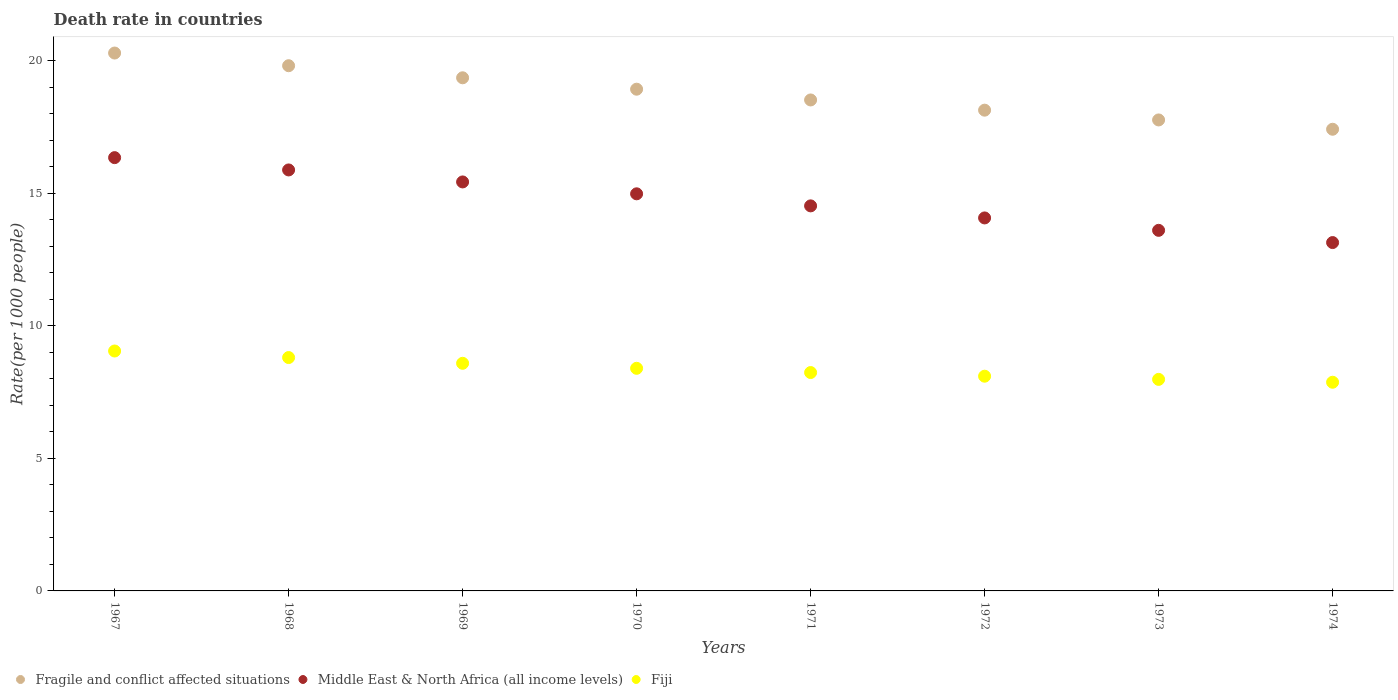How many different coloured dotlines are there?
Your answer should be very brief. 3. Is the number of dotlines equal to the number of legend labels?
Offer a very short reply. Yes. What is the death rate in Fragile and conflict affected situations in 1973?
Your answer should be compact. 17.77. Across all years, what is the maximum death rate in Fiji?
Give a very brief answer. 9.05. Across all years, what is the minimum death rate in Fiji?
Your answer should be very brief. 7.88. In which year was the death rate in Fragile and conflict affected situations maximum?
Keep it short and to the point. 1967. In which year was the death rate in Fragile and conflict affected situations minimum?
Provide a succinct answer. 1974. What is the total death rate in Fragile and conflict affected situations in the graph?
Your answer should be very brief. 150.28. What is the difference between the death rate in Middle East & North Africa (all income levels) in 1968 and that in 1973?
Your answer should be very brief. 2.28. What is the difference between the death rate in Middle East & North Africa (all income levels) in 1969 and the death rate in Fiji in 1973?
Ensure brevity in your answer.  7.45. What is the average death rate in Middle East & North Africa (all income levels) per year?
Provide a succinct answer. 14.75. In the year 1974, what is the difference between the death rate in Fiji and death rate in Fragile and conflict affected situations?
Your answer should be compact. -9.55. In how many years, is the death rate in Middle East & North Africa (all income levels) greater than 15?
Provide a succinct answer. 3. What is the ratio of the death rate in Fiji in 1969 to that in 1974?
Provide a succinct answer. 1.09. Is the death rate in Fiji in 1969 less than that in 1972?
Offer a terse response. No. What is the difference between the highest and the second highest death rate in Fragile and conflict affected situations?
Your response must be concise. 0.48. What is the difference between the highest and the lowest death rate in Fiji?
Ensure brevity in your answer.  1.18. In how many years, is the death rate in Fiji greater than the average death rate in Fiji taken over all years?
Give a very brief answer. 4. Is the sum of the death rate in Fragile and conflict affected situations in 1970 and 1972 greater than the maximum death rate in Fiji across all years?
Provide a short and direct response. Yes. Is it the case that in every year, the sum of the death rate in Fiji and death rate in Middle East & North Africa (all income levels)  is greater than the death rate in Fragile and conflict affected situations?
Provide a short and direct response. Yes. Is the death rate in Fragile and conflict affected situations strictly greater than the death rate in Fiji over the years?
Your answer should be very brief. Yes. Is the death rate in Fragile and conflict affected situations strictly less than the death rate in Middle East & North Africa (all income levels) over the years?
Provide a succinct answer. No. How many dotlines are there?
Ensure brevity in your answer.  3. What is the difference between two consecutive major ticks on the Y-axis?
Keep it short and to the point. 5. Are the values on the major ticks of Y-axis written in scientific E-notation?
Provide a short and direct response. No. Does the graph contain any zero values?
Offer a very short reply. No. Does the graph contain grids?
Give a very brief answer. No. Where does the legend appear in the graph?
Give a very brief answer. Bottom left. How are the legend labels stacked?
Offer a terse response. Horizontal. What is the title of the graph?
Make the answer very short. Death rate in countries. Does "Benin" appear as one of the legend labels in the graph?
Your answer should be compact. No. What is the label or title of the X-axis?
Make the answer very short. Years. What is the label or title of the Y-axis?
Your response must be concise. Rate(per 1000 people). What is the Rate(per 1000 people) of Fragile and conflict affected situations in 1967?
Offer a very short reply. 20.3. What is the Rate(per 1000 people) in Middle East & North Africa (all income levels) in 1967?
Provide a short and direct response. 16.35. What is the Rate(per 1000 people) of Fiji in 1967?
Provide a short and direct response. 9.05. What is the Rate(per 1000 people) in Fragile and conflict affected situations in 1968?
Ensure brevity in your answer.  19.82. What is the Rate(per 1000 people) in Middle East & North Africa (all income levels) in 1968?
Provide a short and direct response. 15.89. What is the Rate(per 1000 people) in Fiji in 1968?
Ensure brevity in your answer.  8.81. What is the Rate(per 1000 people) of Fragile and conflict affected situations in 1969?
Make the answer very short. 19.36. What is the Rate(per 1000 people) in Middle East & North Africa (all income levels) in 1969?
Provide a short and direct response. 15.43. What is the Rate(per 1000 people) in Fiji in 1969?
Make the answer very short. 8.59. What is the Rate(per 1000 people) in Fragile and conflict affected situations in 1970?
Your answer should be very brief. 18.93. What is the Rate(per 1000 people) in Middle East & North Africa (all income levels) in 1970?
Offer a terse response. 14.99. What is the Rate(per 1000 people) of Fiji in 1970?
Provide a succinct answer. 8.4. What is the Rate(per 1000 people) of Fragile and conflict affected situations in 1971?
Your answer should be compact. 18.53. What is the Rate(per 1000 people) in Middle East & North Africa (all income levels) in 1971?
Your answer should be very brief. 14.53. What is the Rate(per 1000 people) of Fiji in 1971?
Keep it short and to the point. 8.24. What is the Rate(per 1000 people) of Fragile and conflict affected situations in 1972?
Offer a very short reply. 18.14. What is the Rate(per 1000 people) of Middle East & North Africa (all income levels) in 1972?
Provide a succinct answer. 14.08. What is the Rate(per 1000 people) of Fiji in 1972?
Offer a terse response. 8.1. What is the Rate(per 1000 people) in Fragile and conflict affected situations in 1973?
Your response must be concise. 17.77. What is the Rate(per 1000 people) in Middle East & North Africa (all income levels) in 1973?
Provide a short and direct response. 13.61. What is the Rate(per 1000 people) of Fiji in 1973?
Your answer should be compact. 7.98. What is the Rate(per 1000 people) in Fragile and conflict affected situations in 1974?
Ensure brevity in your answer.  17.42. What is the Rate(per 1000 people) of Middle East & North Africa (all income levels) in 1974?
Offer a terse response. 13.15. What is the Rate(per 1000 people) in Fiji in 1974?
Offer a terse response. 7.88. Across all years, what is the maximum Rate(per 1000 people) of Fragile and conflict affected situations?
Provide a short and direct response. 20.3. Across all years, what is the maximum Rate(per 1000 people) in Middle East & North Africa (all income levels)?
Offer a terse response. 16.35. Across all years, what is the maximum Rate(per 1000 people) of Fiji?
Give a very brief answer. 9.05. Across all years, what is the minimum Rate(per 1000 people) of Fragile and conflict affected situations?
Your response must be concise. 17.42. Across all years, what is the minimum Rate(per 1000 people) of Middle East & North Africa (all income levels)?
Your answer should be very brief. 13.15. Across all years, what is the minimum Rate(per 1000 people) in Fiji?
Provide a succinct answer. 7.88. What is the total Rate(per 1000 people) of Fragile and conflict affected situations in the graph?
Your response must be concise. 150.28. What is the total Rate(per 1000 people) of Middle East & North Africa (all income levels) in the graph?
Ensure brevity in your answer.  118.02. What is the total Rate(per 1000 people) of Fiji in the graph?
Provide a short and direct response. 67.05. What is the difference between the Rate(per 1000 people) of Fragile and conflict affected situations in 1967 and that in 1968?
Give a very brief answer. 0.48. What is the difference between the Rate(per 1000 people) in Middle East & North Africa (all income levels) in 1967 and that in 1968?
Offer a very short reply. 0.46. What is the difference between the Rate(per 1000 people) in Fiji in 1967 and that in 1968?
Offer a very short reply. 0.25. What is the difference between the Rate(per 1000 people) of Fragile and conflict affected situations in 1967 and that in 1969?
Give a very brief answer. 0.93. What is the difference between the Rate(per 1000 people) of Middle East & North Africa (all income levels) in 1967 and that in 1969?
Your response must be concise. 0.92. What is the difference between the Rate(per 1000 people) in Fiji in 1967 and that in 1969?
Keep it short and to the point. 0.46. What is the difference between the Rate(per 1000 people) of Fragile and conflict affected situations in 1967 and that in 1970?
Your answer should be very brief. 1.36. What is the difference between the Rate(per 1000 people) of Middle East & North Africa (all income levels) in 1967 and that in 1970?
Ensure brevity in your answer.  1.37. What is the difference between the Rate(per 1000 people) of Fiji in 1967 and that in 1970?
Your answer should be compact. 0.65. What is the difference between the Rate(per 1000 people) in Fragile and conflict affected situations in 1967 and that in 1971?
Keep it short and to the point. 1.77. What is the difference between the Rate(per 1000 people) in Middle East & North Africa (all income levels) in 1967 and that in 1971?
Keep it short and to the point. 1.82. What is the difference between the Rate(per 1000 people) of Fiji in 1967 and that in 1971?
Offer a terse response. 0.81. What is the difference between the Rate(per 1000 people) of Fragile and conflict affected situations in 1967 and that in 1972?
Offer a very short reply. 2.16. What is the difference between the Rate(per 1000 people) of Middle East & North Africa (all income levels) in 1967 and that in 1972?
Make the answer very short. 2.28. What is the difference between the Rate(per 1000 people) in Fiji in 1967 and that in 1972?
Give a very brief answer. 0.95. What is the difference between the Rate(per 1000 people) in Fragile and conflict affected situations in 1967 and that in 1973?
Offer a very short reply. 2.52. What is the difference between the Rate(per 1000 people) of Middle East & North Africa (all income levels) in 1967 and that in 1973?
Offer a very short reply. 2.74. What is the difference between the Rate(per 1000 people) of Fiji in 1967 and that in 1973?
Give a very brief answer. 1.07. What is the difference between the Rate(per 1000 people) in Fragile and conflict affected situations in 1967 and that in 1974?
Keep it short and to the point. 2.88. What is the difference between the Rate(per 1000 people) of Middle East & North Africa (all income levels) in 1967 and that in 1974?
Give a very brief answer. 3.21. What is the difference between the Rate(per 1000 people) of Fiji in 1967 and that in 1974?
Your answer should be compact. 1.18. What is the difference between the Rate(per 1000 people) in Fragile and conflict affected situations in 1968 and that in 1969?
Ensure brevity in your answer.  0.46. What is the difference between the Rate(per 1000 people) in Middle East & North Africa (all income levels) in 1968 and that in 1969?
Your answer should be very brief. 0.45. What is the difference between the Rate(per 1000 people) in Fiji in 1968 and that in 1969?
Keep it short and to the point. 0.22. What is the difference between the Rate(per 1000 people) of Fragile and conflict affected situations in 1968 and that in 1970?
Your answer should be very brief. 0.89. What is the difference between the Rate(per 1000 people) in Middle East & North Africa (all income levels) in 1968 and that in 1970?
Your response must be concise. 0.9. What is the difference between the Rate(per 1000 people) in Fiji in 1968 and that in 1970?
Provide a succinct answer. 0.41. What is the difference between the Rate(per 1000 people) in Fragile and conflict affected situations in 1968 and that in 1971?
Make the answer very short. 1.29. What is the difference between the Rate(per 1000 people) of Middle East & North Africa (all income levels) in 1968 and that in 1971?
Provide a short and direct response. 1.36. What is the difference between the Rate(per 1000 people) in Fiji in 1968 and that in 1971?
Make the answer very short. 0.57. What is the difference between the Rate(per 1000 people) in Fragile and conflict affected situations in 1968 and that in 1972?
Ensure brevity in your answer.  1.68. What is the difference between the Rate(per 1000 people) of Middle East & North Africa (all income levels) in 1968 and that in 1972?
Make the answer very short. 1.81. What is the difference between the Rate(per 1000 people) in Fiji in 1968 and that in 1972?
Offer a terse response. 0.7. What is the difference between the Rate(per 1000 people) in Fragile and conflict affected situations in 1968 and that in 1973?
Provide a succinct answer. 2.05. What is the difference between the Rate(per 1000 people) in Middle East & North Africa (all income levels) in 1968 and that in 1973?
Your answer should be very brief. 2.28. What is the difference between the Rate(per 1000 people) of Fiji in 1968 and that in 1973?
Provide a succinct answer. 0.82. What is the difference between the Rate(per 1000 people) of Fragile and conflict affected situations in 1968 and that in 1974?
Provide a short and direct response. 2.4. What is the difference between the Rate(per 1000 people) of Middle East & North Africa (all income levels) in 1968 and that in 1974?
Provide a short and direct response. 2.74. What is the difference between the Rate(per 1000 people) in Fiji in 1968 and that in 1974?
Ensure brevity in your answer.  0.93. What is the difference between the Rate(per 1000 people) in Fragile and conflict affected situations in 1969 and that in 1970?
Keep it short and to the point. 0.43. What is the difference between the Rate(per 1000 people) in Middle East & North Africa (all income levels) in 1969 and that in 1970?
Your answer should be compact. 0.45. What is the difference between the Rate(per 1000 people) in Fiji in 1969 and that in 1970?
Your answer should be very brief. 0.19. What is the difference between the Rate(per 1000 people) in Fragile and conflict affected situations in 1969 and that in 1971?
Ensure brevity in your answer.  0.84. What is the difference between the Rate(per 1000 people) in Middle East & North Africa (all income levels) in 1969 and that in 1971?
Your answer should be compact. 0.9. What is the difference between the Rate(per 1000 people) in Fiji in 1969 and that in 1971?
Ensure brevity in your answer.  0.35. What is the difference between the Rate(per 1000 people) of Fragile and conflict affected situations in 1969 and that in 1972?
Your answer should be very brief. 1.22. What is the difference between the Rate(per 1000 people) of Middle East & North Africa (all income levels) in 1969 and that in 1972?
Provide a succinct answer. 1.36. What is the difference between the Rate(per 1000 people) in Fiji in 1969 and that in 1972?
Ensure brevity in your answer.  0.49. What is the difference between the Rate(per 1000 people) of Fragile and conflict affected situations in 1969 and that in 1973?
Offer a very short reply. 1.59. What is the difference between the Rate(per 1000 people) in Middle East & North Africa (all income levels) in 1969 and that in 1973?
Your response must be concise. 1.83. What is the difference between the Rate(per 1000 people) in Fiji in 1969 and that in 1973?
Keep it short and to the point. 0.61. What is the difference between the Rate(per 1000 people) in Fragile and conflict affected situations in 1969 and that in 1974?
Offer a very short reply. 1.94. What is the difference between the Rate(per 1000 people) of Middle East & North Africa (all income levels) in 1969 and that in 1974?
Provide a short and direct response. 2.29. What is the difference between the Rate(per 1000 people) in Fiji in 1969 and that in 1974?
Offer a terse response. 0.71. What is the difference between the Rate(per 1000 people) in Fragile and conflict affected situations in 1970 and that in 1971?
Keep it short and to the point. 0.41. What is the difference between the Rate(per 1000 people) of Middle East & North Africa (all income levels) in 1970 and that in 1971?
Your answer should be very brief. 0.46. What is the difference between the Rate(per 1000 people) in Fiji in 1970 and that in 1971?
Keep it short and to the point. 0.16. What is the difference between the Rate(per 1000 people) of Fragile and conflict affected situations in 1970 and that in 1972?
Keep it short and to the point. 0.79. What is the difference between the Rate(per 1000 people) in Middle East & North Africa (all income levels) in 1970 and that in 1972?
Ensure brevity in your answer.  0.91. What is the difference between the Rate(per 1000 people) of Fiji in 1970 and that in 1972?
Your response must be concise. 0.3. What is the difference between the Rate(per 1000 people) of Fragile and conflict affected situations in 1970 and that in 1973?
Make the answer very short. 1.16. What is the difference between the Rate(per 1000 people) of Middle East & North Africa (all income levels) in 1970 and that in 1973?
Your response must be concise. 1.38. What is the difference between the Rate(per 1000 people) of Fiji in 1970 and that in 1973?
Provide a succinct answer. 0.42. What is the difference between the Rate(per 1000 people) in Fragile and conflict affected situations in 1970 and that in 1974?
Keep it short and to the point. 1.51. What is the difference between the Rate(per 1000 people) in Middle East & North Africa (all income levels) in 1970 and that in 1974?
Give a very brief answer. 1.84. What is the difference between the Rate(per 1000 people) in Fiji in 1970 and that in 1974?
Keep it short and to the point. 0.53. What is the difference between the Rate(per 1000 people) of Fragile and conflict affected situations in 1971 and that in 1972?
Ensure brevity in your answer.  0.39. What is the difference between the Rate(per 1000 people) of Middle East & North Africa (all income levels) in 1971 and that in 1972?
Make the answer very short. 0.45. What is the difference between the Rate(per 1000 people) in Fiji in 1971 and that in 1972?
Ensure brevity in your answer.  0.14. What is the difference between the Rate(per 1000 people) of Fragile and conflict affected situations in 1971 and that in 1973?
Provide a succinct answer. 0.75. What is the difference between the Rate(per 1000 people) in Middle East & North Africa (all income levels) in 1971 and that in 1973?
Your answer should be compact. 0.92. What is the difference between the Rate(per 1000 people) of Fiji in 1971 and that in 1973?
Offer a very short reply. 0.26. What is the difference between the Rate(per 1000 people) in Fragile and conflict affected situations in 1971 and that in 1974?
Make the answer very short. 1.11. What is the difference between the Rate(per 1000 people) in Middle East & North Africa (all income levels) in 1971 and that in 1974?
Offer a terse response. 1.38. What is the difference between the Rate(per 1000 people) in Fiji in 1971 and that in 1974?
Offer a very short reply. 0.37. What is the difference between the Rate(per 1000 people) of Fragile and conflict affected situations in 1972 and that in 1973?
Give a very brief answer. 0.37. What is the difference between the Rate(per 1000 people) in Middle East & North Africa (all income levels) in 1972 and that in 1973?
Your answer should be compact. 0.47. What is the difference between the Rate(per 1000 people) in Fiji in 1972 and that in 1973?
Give a very brief answer. 0.12. What is the difference between the Rate(per 1000 people) of Fragile and conflict affected situations in 1972 and that in 1974?
Your answer should be very brief. 0.72. What is the difference between the Rate(per 1000 people) in Middle East & North Africa (all income levels) in 1972 and that in 1974?
Give a very brief answer. 0.93. What is the difference between the Rate(per 1000 people) in Fiji in 1972 and that in 1974?
Provide a succinct answer. 0.23. What is the difference between the Rate(per 1000 people) of Fragile and conflict affected situations in 1973 and that in 1974?
Provide a short and direct response. 0.35. What is the difference between the Rate(per 1000 people) of Middle East & North Africa (all income levels) in 1973 and that in 1974?
Keep it short and to the point. 0.46. What is the difference between the Rate(per 1000 people) of Fiji in 1973 and that in 1974?
Provide a short and direct response. 0.11. What is the difference between the Rate(per 1000 people) of Fragile and conflict affected situations in 1967 and the Rate(per 1000 people) of Middle East & North Africa (all income levels) in 1968?
Offer a terse response. 4.41. What is the difference between the Rate(per 1000 people) in Fragile and conflict affected situations in 1967 and the Rate(per 1000 people) in Fiji in 1968?
Provide a short and direct response. 11.49. What is the difference between the Rate(per 1000 people) in Middle East & North Africa (all income levels) in 1967 and the Rate(per 1000 people) in Fiji in 1968?
Give a very brief answer. 7.54. What is the difference between the Rate(per 1000 people) of Fragile and conflict affected situations in 1967 and the Rate(per 1000 people) of Middle East & North Africa (all income levels) in 1969?
Your response must be concise. 4.86. What is the difference between the Rate(per 1000 people) in Fragile and conflict affected situations in 1967 and the Rate(per 1000 people) in Fiji in 1969?
Make the answer very short. 11.71. What is the difference between the Rate(per 1000 people) in Middle East & North Africa (all income levels) in 1967 and the Rate(per 1000 people) in Fiji in 1969?
Give a very brief answer. 7.76. What is the difference between the Rate(per 1000 people) in Fragile and conflict affected situations in 1967 and the Rate(per 1000 people) in Middle East & North Africa (all income levels) in 1970?
Make the answer very short. 5.31. What is the difference between the Rate(per 1000 people) of Fragile and conflict affected situations in 1967 and the Rate(per 1000 people) of Fiji in 1970?
Provide a succinct answer. 11.9. What is the difference between the Rate(per 1000 people) in Middle East & North Africa (all income levels) in 1967 and the Rate(per 1000 people) in Fiji in 1970?
Offer a very short reply. 7.95. What is the difference between the Rate(per 1000 people) of Fragile and conflict affected situations in 1967 and the Rate(per 1000 people) of Middle East & North Africa (all income levels) in 1971?
Provide a succinct answer. 5.77. What is the difference between the Rate(per 1000 people) of Fragile and conflict affected situations in 1967 and the Rate(per 1000 people) of Fiji in 1971?
Keep it short and to the point. 12.06. What is the difference between the Rate(per 1000 people) of Middle East & North Africa (all income levels) in 1967 and the Rate(per 1000 people) of Fiji in 1971?
Offer a very short reply. 8.11. What is the difference between the Rate(per 1000 people) in Fragile and conflict affected situations in 1967 and the Rate(per 1000 people) in Middle East & North Africa (all income levels) in 1972?
Make the answer very short. 6.22. What is the difference between the Rate(per 1000 people) in Fragile and conflict affected situations in 1967 and the Rate(per 1000 people) in Fiji in 1972?
Offer a very short reply. 12.2. What is the difference between the Rate(per 1000 people) of Middle East & North Africa (all income levels) in 1967 and the Rate(per 1000 people) of Fiji in 1972?
Keep it short and to the point. 8.25. What is the difference between the Rate(per 1000 people) in Fragile and conflict affected situations in 1967 and the Rate(per 1000 people) in Middle East & North Africa (all income levels) in 1973?
Offer a very short reply. 6.69. What is the difference between the Rate(per 1000 people) in Fragile and conflict affected situations in 1967 and the Rate(per 1000 people) in Fiji in 1973?
Offer a very short reply. 12.32. What is the difference between the Rate(per 1000 people) in Middle East & North Africa (all income levels) in 1967 and the Rate(per 1000 people) in Fiji in 1973?
Your response must be concise. 8.37. What is the difference between the Rate(per 1000 people) of Fragile and conflict affected situations in 1967 and the Rate(per 1000 people) of Middle East & North Africa (all income levels) in 1974?
Keep it short and to the point. 7.15. What is the difference between the Rate(per 1000 people) of Fragile and conflict affected situations in 1967 and the Rate(per 1000 people) of Fiji in 1974?
Provide a succinct answer. 12.42. What is the difference between the Rate(per 1000 people) in Middle East & North Africa (all income levels) in 1967 and the Rate(per 1000 people) in Fiji in 1974?
Provide a succinct answer. 8.48. What is the difference between the Rate(per 1000 people) in Fragile and conflict affected situations in 1968 and the Rate(per 1000 people) in Middle East & North Africa (all income levels) in 1969?
Your answer should be very brief. 4.39. What is the difference between the Rate(per 1000 people) of Fragile and conflict affected situations in 1968 and the Rate(per 1000 people) of Fiji in 1969?
Offer a terse response. 11.23. What is the difference between the Rate(per 1000 people) of Middle East & North Africa (all income levels) in 1968 and the Rate(per 1000 people) of Fiji in 1969?
Provide a succinct answer. 7.3. What is the difference between the Rate(per 1000 people) in Fragile and conflict affected situations in 1968 and the Rate(per 1000 people) in Middle East & North Africa (all income levels) in 1970?
Your answer should be very brief. 4.83. What is the difference between the Rate(per 1000 people) of Fragile and conflict affected situations in 1968 and the Rate(per 1000 people) of Fiji in 1970?
Keep it short and to the point. 11.42. What is the difference between the Rate(per 1000 people) of Middle East & North Africa (all income levels) in 1968 and the Rate(per 1000 people) of Fiji in 1970?
Your answer should be very brief. 7.49. What is the difference between the Rate(per 1000 people) in Fragile and conflict affected situations in 1968 and the Rate(per 1000 people) in Middle East & North Africa (all income levels) in 1971?
Provide a short and direct response. 5.29. What is the difference between the Rate(per 1000 people) in Fragile and conflict affected situations in 1968 and the Rate(per 1000 people) in Fiji in 1971?
Offer a terse response. 11.58. What is the difference between the Rate(per 1000 people) in Middle East & North Africa (all income levels) in 1968 and the Rate(per 1000 people) in Fiji in 1971?
Your answer should be very brief. 7.65. What is the difference between the Rate(per 1000 people) of Fragile and conflict affected situations in 1968 and the Rate(per 1000 people) of Middle East & North Africa (all income levels) in 1972?
Your response must be concise. 5.74. What is the difference between the Rate(per 1000 people) of Fragile and conflict affected situations in 1968 and the Rate(per 1000 people) of Fiji in 1972?
Give a very brief answer. 11.72. What is the difference between the Rate(per 1000 people) in Middle East & North Africa (all income levels) in 1968 and the Rate(per 1000 people) in Fiji in 1972?
Your answer should be very brief. 7.78. What is the difference between the Rate(per 1000 people) of Fragile and conflict affected situations in 1968 and the Rate(per 1000 people) of Middle East & North Africa (all income levels) in 1973?
Offer a terse response. 6.21. What is the difference between the Rate(per 1000 people) in Fragile and conflict affected situations in 1968 and the Rate(per 1000 people) in Fiji in 1973?
Give a very brief answer. 11.84. What is the difference between the Rate(per 1000 people) in Middle East & North Africa (all income levels) in 1968 and the Rate(per 1000 people) in Fiji in 1973?
Your answer should be compact. 7.9. What is the difference between the Rate(per 1000 people) in Fragile and conflict affected situations in 1968 and the Rate(per 1000 people) in Middle East & North Africa (all income levels) in 1974?
Your answer should be very brief. 6.67. What is the difference between the Rate(per 1000 people) in Fragile and conflict affected situations in 1968 and the Rate(per 1000 people) in Fiji in 1974?
Make the answer very short. 11.95. What is the difference between the Rate(per 1000 people) of Middle East & North Africa (all income levels) in 1968 and the Rate(per 1000 people) of Fiji in 1974?
Keep it short and to the point. 8.01. What is the difference between the Rate(per 1000 people) in Fragile and conflict affected situations in 1969 and the Rate(per 1000 people) in Middle East & North Africa (all income levels) in 1970?
Offer a terse response. 4.38. What is the difference between the Rate(per 1000 people) in Fragile and conflict affected situations in 1969 and the Rate(per 1000 people) in Fiji in 1970?
Your answer should be compact. 10.96. What is the difference between the Rate(per 1000 people) in Middle East & North Africa (all income levels) in 1969 and the Rate(per 1000 people) in Fiji in 1970?
Your answer should be very brief. 7.03. What is the difference between the Rate(per 1000 people) in Fragile and conflict affected situations in 1969 and the Rate(per 1000 people) in Middle East & North Africa (all income levels) in 1971?
Make the answer very short. 4.83. What is the difference between the Rate(per 1000 people) in Fragile and conflict affected situations in 1969 and the Rate(per 1000 people) in Fiji in 1971?
Make the answer very short. 11.12. What is the difference between the Rate(per 1000 people) in Middle East & North Africa (all income levels) in 1969 and the Rate(per 1000 people) in Fiji in 1971?
Provide a short and direct response. 7.19. What is the difference between the Rate(per 1000 people) of Fragile and conflict affected situations in 1969 and the Rate(per 1000 people) of Middle East & North Africa (all income levels) in 1972?
Your answer should be very brief. 5.29. What is the difference between the Rate(per 1000 people) of Fragile and conflict affected situations in 1969 and the Rate(per 1000 people) of Fiji in 1972?
Offer a terse response. 11.26. What is the difference between the Rate(per 1000 people) of Middle East & North Africa (all income levels) in 1969 and the Rate(per 1000 people) of Fiji in 1972?
Offer a very short reply. 7.33. What is the difference between the Rate(per 1000 people) of Fragile and conflict affected situations in 1969 and the Rate(per 1000 people) of Middle East & North Africa (all income levels) in 1973?
Your answer should be very brief. 5.76. What is the difference between the Rate(per 1000 people) in Fragile and conflict affected situations in 1969 and the Rate(per 1000 people) in Fiji in 1973?
Your answer should be compact. 11.38. What is the difference between the Rate(per 1000 people) in Middle East & North Africa (all income levels) in 1969 and the Rate(per 1000 people) in Fiji in 1973?
Make the answer very short. 7.45. What is the difference between the Rate(per 1000 people) in Fragile and conflict affected situations in 1969 and the Rate(per 1000 people) in Middle East & North Africa (all income levels) in 1974?
Provide a succinct answer. 6.22. What is the difference between the Rate(per 1000 people) of Fragile and conflict affected situations in 1969 and the Rate(per 1000 people) of Fiji in 1974?
Offer a very short reply. 11.49. What is the difference between the Rate(per 1000 people) of Middle East & North Africa (all income levels) in 1969 and the Rate(per 1000 people) of Fiji in 1974?
Your answer should be compact. 7.56. What is the difference between the Rate(per 1000 people) in Fragile and conflict affected situations in 1970 and the Rate(per 1000 people) in Middle East & North Africa (all income levels) in 1971?
Keep it short and to the point. 4.4. What is the difference between the Rate(per 1000 people) in Fragile and conflict affected situations in 1970 and the Rate(per 1000 people) in Fiji in 1971?
Ensure brevity in your answer.  10.69. What is the difference between the Rate(per 1000 people) in Middle East & North Africa (all income levels) in 1970 and the Rate(per 1000 people) in Fiji in 1971?
Your answer should be compact. 6.75. What is the difference between the Rate(per 1000 people) of Fragile and conflict affected situations in 1970 and the Rate(per 1000 people) of Middle East & North Africa (all income levels) in 1972?
Make the answer very short. 4.86. What is the difference between the Rate(per 1000 people) in Fragile and conflict affected situations in 1970 and the Rate(per 1000 people) in Fiji in 1972?
Provide a succinct answer. 10.83. What is the difference between the Rate(per 1000 people) of Middle East & North Africa (all income levels) in 1970 and the Rate(per 1000 people) of Fiji in 1972?
Provide a short and direct response. 6.88. What is the difference between the Rate(per 1000 people) in Fragile and conflict affected situations in 1970 and the Rate(per 1000 people) in Middle East & North Africa (all income levels) in 1973?
Your answer should be compact. 5.33. What is the difference between the Rate(per 1000 people) in Fragile and conflict affected situations in 1970 and the Rate(per 1000 people) in Fiji in 1973?
Offer a terse response. 10.95. What is the difference between the Rate(per 1000 people) of Middle East & North Africa (all income levels) in 1970 and the Rate(per 1000 people) of Fiji in 1973?
Make the answer very short. 7. What is the difference between the Rate(per 1000 people) of Fragile and conflict affected situations in 1970 and the Rate(per 1000 people) of Middle East & North Africa (all income levels) in 1974?
Provide a short and direct response. 5.79. What is the difference between the Rate(per 1000 people) of Fragile and conflict affected situations in 1970 and the Rate(per 1000 people) of Fiji in 1974?
Provide a short and direct response. 11.06. What is the difference between the Rate(per 1000 people) of Middle East & North Africa (all income levels) in 1970 and the Rate(per 1000 people) of Fiji in 1974?
Provide a succinct answer. 7.11. What is the difference between the Rate(per 1000 people) of Fragile and conflict affected situations in 1971 and the Rate(per 1000 people) of Middle East & North Africa (all income levels) in 1972?
Your answer should be compact. 4.45. What is the difference between the Rate(per 1000 people) of Fragile and conflict affected situations in 1971 and the Rate(per 1000 people) of Fiji in 1972?
Your answer should be very brief. 10.43. What is the difference between the Rate(per 1000 people) of Middle East & North Africa (all income levels) in 1971 and the Rate(per 1000 people) of Fiji in 1972?
Offer a terse response. 6.43. What is the difference between the Rate(per 1000 people) in Fragile and conflict affected situations in 1971 and the Rate(per 1000 people) in Middle East & North Africa (all income levels) in 1973?
Ensure brevity in your answer.  4.92. What is the difference between the Rate(per 1000 people) in Fragile and conflict affected situations in 1971 and the Rate(per 1000 people) in Fiji in 1973?
Your answer should be compact. 10.55. What is the difference between the Rate(per 1000 people) in Middle East & North Africa (all income levels) in 1971 and the Rate(per 1000 people) in Fiji in 1973?
Provide a succinct answer. 6.55. What is the difference between the Rate(per 1000 people) in Fragile and conflict affected situations in 1971 and the Rate(per 1000 people) in Middle East & North Africa (all income levels) in 1974?
Your answer should be compact. 5.38. What is the difference between the Rate(per 1000 people) in Fragile and conflict affected situations in 1971 and the Rate(per 1000 people) in Fiji in 1974?
Offer a very short reply. 10.65. What is the difference between the Rate(per 1000 people) of Middle East & North Africa (all income levels) in 1971 and the Rate(per 1000 people) of Fiji in 1974?
Ensure brevity in your answer.  6.66. What is the difference between the Rate(per 1000 people) in Fragile and conflict affected situations in 1972 and the Rate(per 1000 people) in Middle East & North Africa (all income levels) in 1973?
Ensure brevity in your answer.  4.54. What is the difference between the Rate(per 1000 people) of Fragile and conflict affected situations in 1972 and the Rate(per 1000 people) of Fiji in 1973?
Your answer should be very brief. 10.16. What is the difference between the Rate(per 1000 people) in Middle East & North Africa (all income levels) in 1972 and the Rate(per 1000 people) in Fiji in 1973?
Offer a very short reply. 6.09. What is the difference between the Rate(per 1000 people) of Fragile and conflict affected situations in 1972 and the Rate(per 1000 people) of Middle East & North Africa (all income levels) in 1974?
Offer a very short reply. 5. What is the difference between the Rate(per 1000 people) of Fragile and conflict affected situations in 1972 and the Rate(per 1000 people) of Fiji in 1974?
Ensure brevity in your answer.  10.27. What is the difference between the Rate(per 1000 people) of Middle East & North Africa (all income levels) in 1972 and the Rate(per 1000 people) of Fiji in 1974?
Offer a very short reply. 6.2. What is the difference between the Rate(per 1000 people) of Fragile and conflict affected situations in 1973 and the Rate(per 1000 people) of Middle East & North Africa (all income levels) in 1974?
Give a very brief answer. 4.63. What is the difference between the Rate(per 1000 people) in Fragile and conflict affected situations in 1973 and the Rate(per 1000 people) in Fiji in 1974?
Offer a terse response. 9.9. What is the difference between the Rate(per 1000 people) of Middle East & North Africa (all income levels) in 1973 and the Rate(per 1000 people) of Fiji in 1974?
Provide a succinct answer. 5.73. What is the average Rate(per 1000 people) of Fragile and conflict affected situations per year?
Your answer should be compact. 18.79. What is the average Rate(per 1000 people) of Middle East & North Africa (all income levels) per year?
Provide a succinct answer. 14.75. What is the average Rate(per 1000 people) in Fiji per year?
Your answer should be compact. 8.38. In the year 1967, what is the difference between the Rate(per 1000 people) in Fragile and conflict affected situations and Rate(per 1000 people) in Middle East & North Africa (all income levels)?
Offer a very short reply. 3.95. In the year 1967, what is the difference between the Rate(per 1000 people) of Fragile and conflict affected situations and Rate(per 1000 people) of Fiji?
Your answer should be very brief. 11.24. In the year 1967, what is the difference between the Rate(per 1000 people) of Middle East & North Africa (all income levels) and Rate(per 1000 people) of Fiji?
Ensure brevity in your answer.  7.3. In the year 1968, what is the difference between the Rate(per 1000 people) in Fragile and conflict affected situations and Rate(per 1000 people) in Middle East & North Africa (all income levels)?
Keep it short and to the point. 3.93. In the year 1968, what is the difference between the Rate(per 1000 people) in Fragile and conflict affected situations and Rate(per 1000 people) in Fiji?
Offer a very short reply. 11.01. In the year 1968, what is the difference between the Rate(per 1000 people) of Middle East & North Africa (all income levels) and Rate(per 1000 people) of Fiji?
Offer a very short reply. 7.08. In the year 1969, what is the difference between the Rate(per 1000 people) of Fragile and conflict affected situations and Rate(per 1000 people) of Middle East & North Africa (all income levels)?
Provide a short and direct response. 3.93. In the year 1969, what is the difference between the Rate(per 1000 people) of Fragile and conflict affected situations and Rate(per 1000 people) of Fiji?
Keep it short and to the point. 10.77. In the year 1969, what is the difference between the Rate(per 1000 people) of Middle East & North Africa (all income levels) and Rate(per 1000 people) of Fiji?
Provide a short and direct response. 6.84. In the year 1970, what is the difference between the Rate(per 1000 people) of Fragile and conflict affected situations and Rate(per 1000 people) of Middle East & North Africa (all income levels)?
Keep it short and to the point. 3.95. In the year 1970, what is the difference between the Rate(per 1000 people) of Fragile and conflict affected situations and Rate(per 1000 people) of Fiji?
Your answer should be very brief. 10.53. In the year 1970, what is the difference between the Rate(per 1000 people) of Middle East & North Africa (all income levels) and Rate(per 1000 people) of Fiji?
Your answer should be very brief. 6.58. In the year 1971, what is the difference between the Rate(per 1000 people) in Fragile and conflict affected situations and Rate(per 1000 people) in Middle East & North Africa (all income levels)?
Offer a terse response. 4. In the year 1971, what is the difference between the Rate(per 1000 people) in Fragile and conflict affected situations and Rate(per 1000 people) in Fiji?
Offer a terse response. 10.29. In the year 1971, what is the difference between the Rate(per 1000 people) of Middle East & North Africa (all income levels) and Rate(per 1000 people) of Fiji?
Your answer should be very brief. 6.29. In the year 1972, what is the difference between the Rate(per 1000 people) in Fragile and conflict affected situations and Rate(per 1000 people) in Middle East & North Africa (all income levels)?
Provide a succinct answer. 4.07. In the year 1972, what is the difference between the Rate(per 1000 people) of Fragile and conflict affected situations and Rate(per 1000 people) of Fiji?
Provide a short and direct response. 10.04. In the year 1972, what is the difference between the Rate(per 1000 people) of Middle East & North Africa (all income levels) and Rate(per 1000 people) of Fiji?
Make the answer very short. 5.97. In the year 1973, what is the difference between the Rate(per 1000 people) in Fragile and conflict affected situations and Rate(per 1000 people) in Middle East & North Africa (all income levels)?
Ensure brevity in your answer.  4.17. In the year 1973, what is the difference between the Rate(per 1000 people) in Fragile and conflict affected situations and Rate(per 1000 people) in Fiji?
Ensure brevity in your answer.  9.79. In the year 1973, what is the difference between the Rate(per 1000 people) in Middle East & North Africa (all income levels) and Rate(per 1000 people) in Fiji?
Offer a terse response. 5.62. In the year 1974, what is the difference between the Rate(per 1000 people) of Fragile and conflict affected situations and Rate(per 1000 people) of Middle East & North Africa (all income levels)?
Offer a very short reply. 4.28. In the year 1974, what is the difference between the Rate(per 1000 people) in Fragile and conflict affected situations and Rate(per 1000 people) in Fiji?
Ensure brevity in your answer.  9.55. In the year 1974, what is the difference between the Rate(per 1000 people) in Middle East & North Africa (all income levels) and Rate(per 1000 people) in Fiji?
Provide a succinct answer. 5.27. What is the ratio of the Rate(per 1000 people) in Fragile and conflict affected situations in 1967 to that in 1968?
Provide a short and direct response. 1.02. What is the ratio of the Rate(per 1000 people) of Middle East & North Africa (all income levels) in 1967 to that in 1968?
Ensure brevity in your answer.  1.03. What is the ratio of the Rate(per 1000 people) in Fiji in 1967 to that in 1968?
Give a very brief answer. 1.03. What is the ratio of the Rate(per 1000 people) in Fragile and conflict affected situations in 1967 to that in 1969?
Ensure brevity in your answer.  1.05. What is the ratio of the Rate(per 1000 people) of Middle East & North Africa (all income levels) in 1967 to that in 1969?
Offer a very short reply. 1.06. What is the ratio of the Rate(per 1000 people) in Fiji in 1967 to that in 1969?
Ensure brevity in your answer.  1.05. What is the ratio of the Rate(per 1000 people) of Fragile and conflict affected situations in 1967 to that in 1970?
Offer a terse response. 1.07. What is the ratio of the Rate(per 1000 people) in Middle East & North Africa (all income levels) in 1967 to that in 1970?
Provide a short and direct response. 1.09. What is the ratio of the Rate(per 1000 people) of Fiji in 1967 to that in 1970?
Give a very brief answer. 1.08. What is the ratio of the Rate(per 1000 people) of Fragile and conflict affected situations in 1967 to that in 1971?
Keep it short and to the point. 1.1. What is the ratio of the Rate(per 1000 people) of Middle East & North Africa (all income levels) in 1967 to that in 1971?
Your answer should be compact. 1.13. What is the ratio of the Rate(per 1000 people) in Fiji in 1967 to that in 1971?
Offer a very short reply. 1.1. What is the ratio of the Rate(per 1000 people) in Fragile and conflict affected situations in 1967 to that in 1972?
Your response must be concise. 1.12. What is the ratio of the Rate(per 1000 people) in Middle East & North Africa (all income levels) in 1967 to that in 1972?
Make the answer very short. 1.16. What is the ratio of the Rate(per 1000 people) in Fiji in 1967 to that in 1972?
Your response must be concise. 1.12. What is the ratio of the Rate(per 1000 people) in Fragile and conflict affected situations in 1967 to that in 1973?
Make the answer very short. 1.14. What is the ratio of the Rate(per 1000 people) of Middle East & North Africa (all income levels) in 1967 to that in 1973?
Your answer should be very brief. 1.2. What is the ratio of the Rate(per 1000 people) in Fiji in 1967 to that in 1973?
Provide a short and direct response. 1.13. What is the ratio of the Rate(per 1000 people) of Fragile and conflict affected situations in 1967 to that in 1974?
Offer a terse response. 1.17. What is the ratio of the Rate(per 1000 people) of Middle East & North Africa (all income levels) in 1967 to that in 1974?
Make the answer very short. 1.24. What is the ratio of the Rate(per 1000 people) of Fiji in 1967 to that in 1974?
Ensure brevity in your answer.  1.15. What is the ratio of the Rate(per 1000 people) of Fragile and conflict affected situations in 1968 to that in 1969?
Provide a succinct answer. 1.02. What is the ratio of the Rate(per 1000 people) of Middle East & North Africa (all income levels) in 1968 to that in 1969?
Ensure brevity in your answer.  1.03. What is the ratio of the Rate(per 1000 people) of Fiji in 1968 to that in 1969?
Provide a short and direct response. 1.03. What is the ratio of the Rate(per 1000 people) of Fragile and conflict affected situations in 1968 to that in 1970?
Offer a terse response. 1.05. What is the ratio of the Rate(per 1000 people) of Middle East & North Africa (all income levels) in 1968 to that in 1970?
Provide a succinct answer. 1.06. What is the ratio of the Rate(per 1000 people) of Fiji in 1968 to that in 1970?
Your answer should be compact. 1.05. What is the ratio of the Rate(per 1000 people) in Fragile and conflict affected situations in 1968 to that in 1971?
Give a very brief answer. 1.07. What is the ratio of the Rate(per 1000 people) of Middle East & North Africa (all income levels) in 1968 to that in 1971?
Make the answer very short. 1.09. What is the ratio of the Rate(per 1000 people) of Fiji in 1968 to that in 1971?
Offer a very short reply. 1.07. What is the ratio of the Rate(per 1000 people) in Fragile and conflict affected situations in 1968 to that in 1972?
Your answer should be compact. 1.09. What is the ratio of the Rate(per 1000 people) of Middle East & North Africa (all income levels) in 1968 to that in 1972?
Your response must be concise. 1.13. What is the ratio of the Rate(per 1000 people) in Fiji in 1968 to that in 1972?
Your answer should be very brief. 1.09. What is the ratio of the Rate(per 1000 people) in Fragile and conflict affected situations in 1968 to that in 1973?
Offer a terse response. 1.12. What is the ratio of the Rate(per 1000 people) in Middle East & North Africa (all income levels) in 1968 to that in 1973?
Your answer should be compact. 1.17. What is the ratio of the Rate(per 1000 people) of Fiji in 1968 to that in 1973?
Provide a succinct answer. 1.1. What is the ratio of the Rate(per 1000 people) of Fragile and conflict affected situations in 1968 to that in 1974?
Make the answer very short. 1.14. What is the ratio of the Rate(per 1000 people) in Middle East & North Africa (all income levels) in 1968 to that in 1974?
Make the answer very short. 1.21. What is the ratio of the Rate(per 1000 people) in Fiji in 1968 to that in 1974?
Make the answer very short. 1.12. What is the ratio of the Rate(per 1000 people) in Fragile and conflict affected situations in 1969 to that in 1970?
Provide a succinct answer. 1.02. What is the ratio of the Rate(per 1000 people) in Middle East & North Africa (all income levels) in 1969 to that in 1970?
Provide a succinct answer. 1.03. What is the ratio of the Rate(per 1000 people) in Fiji in 1969 to that in 1970?
Provide a short and direct response. 1.02. What is the ratio of the Rate(per 1000 people) of Fragile and conflict affected situations in 1969 to that in 1971?
Give a very brief answer. 1.05. What is the ratio of the Rate(per 1000 people) in Middle East & North Africa (all income levels) in 1969 to that in 1971?
Make the answer very short. 1.06. What is the ratio of the Rate(per 1000 people) of Fiji in 1969 to that in 1971?
Make the answer very short. 1.04. What is the ratio of the Rate(per 1000 people) of Fragile and conflict affected situations in 1969 to that in 1972?
Your response must be concise. 1.07. What is the ratio of the Rate(per 1000 people) in Middle East & North Africa (all income levels) in 1969 to that in 1972?
Ensure brevity in your answer.  1.1. What is the ratio of the Rate(per 1000 people) of Fiji in 1969 to that in 1972?
Give a very brief answer. 1.06. What is the ratio of the Rate(per 1000 people) of Fragile and conflict affected situations in 1969 to that in 1973?
Offer a very short reply. 1.09. What is the ratio of the Rate(per 1000 people) in Middle East & North Africa (all income levels) in 1969 to that in 1973?
Give a very brief answer. 1.13. What is the ratio of the Rate(per 1000 people) in Fiji in 1969 to that in 1973?
Make the answer very short. 1.08. What is the ratio of the Rate(per 1000 people) in Fragile and conflict affected situations in 1969 to that in 1974?
Give a very brief answer. 1.11. What is the ratio of the Rate(per 1000 people) in Middle East & North Africa (all income levels) in 1969 to that in 1974?
Your answer should be compact. 1.17. What is the ratio of the Rate(per 1000 people) in Fiji in 1969 to that in 1974?
Provide a short and direct response. 1.09. What is the ratio of the Rate(per 1000 people) of Fragile and conflict affected situations in 1970 to that in 1971?
Your response must be concise. 1.02. What is the ratio of the Rate(per 1000 people) of Middle East & North Africa (all income levels) in 1970 to that in 1971?
Provide a short and direct response. 1.03. What is the ratio of the Rate(per 1000 people) of Fiji in 1970 to that in 1971?
Give a very brief answer. 1.02. What is the ratio of the Rate(per 1000 people) of Fragile and conflict affected situations in 1970 to that in 1972?
Your response must be concise. 1.04. What is the ratio of the Rate(per 1000 people) of Middle East & North Africa (all income levels) in 1970 to that in 1972?
Make the answer very short. 1.06. What is the ratio of the Rate(per 1000 people) in Fiji in 1970 to that in 1972?
Your answer should be very brief. 1.04. What is the ratio of the Rate(per 1000 people) of Fragile and conflict affected situations in 1970 to that in 1973?
Provide a succinct answer. 1.07. What is the ratio of the Rate(per 1000 people) of Middle East & North Africa (all income levels) in 1970 to that in 1973?
Your answer should be very brief. 1.1. What is the ratio of the Rate(per 1000 people) of Fiji in 1970 to that in 1973?
Provide a short and direct response. 1.05. What is the ratio of the Rate(per 1000 people) in Fragile and conflict affected situations in 1970 to that in 1974?
Ensure brevity in your answer.  1.09. What is the ratio of the Rate(per 1000 people) in Middle East & North Africa (all income levels) in 1970 to that in 1974?
Your answer should be compact. 1.14. What is the ratio of the Rate(per 1000 people) in Fiji in 1970 to that in 1974?
Give a very brief answer. 1.07. What is the ratio of the Rate(per 1000 people) in Fragile and conflict affected situations in 1971 to that in 1972?
Your answer should be very brief. 1.02. What is the ratio of the Rate(per 1000 people) of Middle East & North Africa (all income levels) in 1971 to that in 1972?
Your response must be concise. 1.03. What is the ratio of the Rate(per 1000 people) in Fiji in 1971 to that in 1972?
Keep it short and to the point. 1.02. What is the ratio of the Rate(per 1000 people) of Fragile and conflict affected situations in 1971 to that in 1973?
Your answer should be very brief. 1.04. What is the ratio of the Rate(per 1000 people) of Middle East & North Africa (all income levels) in 1971 to that in 1973?
Offer a very short reply. 1.07. What is the ratio of the Rate(per 1000 people) of Fiji in 1971 to that in 1973?
Make the answer very short. 1.03. What is the ratio of the Rate(per 1000 people) in Fragile and conflict affected situations in 1971 to that in 1974?
Offer a terse response. 1.06. What is the ratio of the Rate(per 1000 people) of Middle East & North Africa (all income levels) in 1971 to that in 1974?
Make the answer very short. 1.11. What is the ratio of the Rate(per 1000 people) of Fiji in 1971 to that in 1974?
Keep it short and to the point. 1.05. What is the ratio of the Rate(per 1000 people) of Fragile and conflict affected situations in 1972 to that in 1973?
Offer a terse response. 1.02. What is the ratio of the Rate(per 1000 people) in Middle East & North Africa (all income levels) in 1972 to that in 1973?
Offer a terse response. 1.03. What is the ratio of the Rate(per 1000 people) of Fiji in 1972 to that in 1973?
Provide a succinct answer. 1.01. What is the ratio of the Rate(per 1000 people) in Fragile and conflict affected situations in 1972 to that in 1974?
Offer a terse response. 1.04. What is the ratio of the Rate(per 1000 people) of Middle East & North Africa (all income levels) in 1972 to that in 1974?
Your answer should be very brief. 1.07. What is the ratio of the Rate(per 1000 people) of Fiji in 1972 to that in 1974?
Ensure brevity in your answer.  1.03. What is the ratio of the Rate(per 1000 people) in Fragile and conflict affected situations in 1973 to that in 1974?
Ensure brevity in your answer.  1.02. What is the ratio of the Rate(per 1000 people) in Middle East & North Africa (all income levels) in 1973 to that in 1974?
Keep it short and to the point. 1.04. What is the ratio of the Rate(per 1000 people) of Fiji in 1973 to that in 1974?
Offer a terse response. 1.01. What is the difference between the highest and the second highest Rate(per 1000 people) of Fragile and conflict affected situations?
Your answer should be compact. 0.48. What is the difference between the highest and the second highest Rate(per 1000 people) of Middle East & North Africa (all income levels)?
Keep it short and to the point. 0.46. What is the difference between the highest and the second highest Rate(per 1000 people) in Fiji?
Offer a very short reply. 0.25. What is the difference between the highest and the lowest Rate(per 1000 people) of Fragile and conflict affected situations?
Keep it short and to the point. 2.88. What is the difference between the highest and the lowest Rate(per 1000 people) in Middle East & North Africa (all income levels)?
Offer a terse response. 3.21. What is the difference between the highest and the lowest Rate(per 1000 people) in Fiji?
Provide a succinct answer. 1.18. 